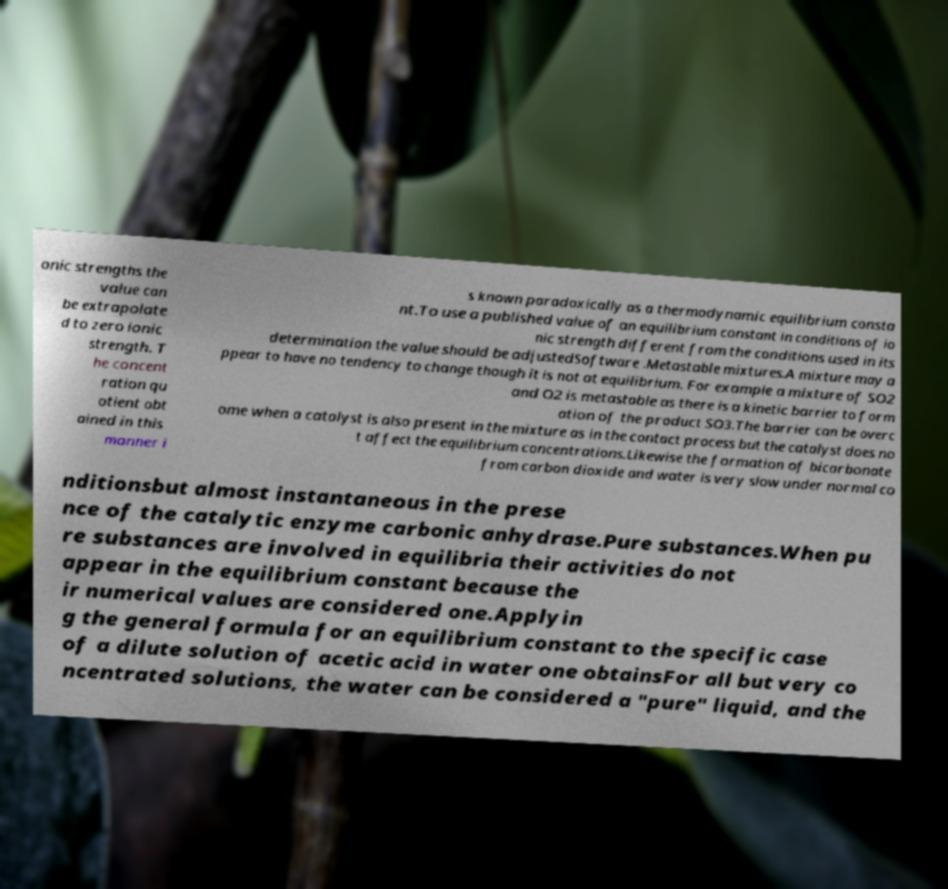Could you extract and type out the text from this image? onic strengths the value can be extrapolate d to zero ionic strength. T he concent ration qu otient obt ained in this manner i s known paradoxically as a thermodynamic equilibrium consta nt.To use a published value of an equilibrium constant in conditions of io nic strength different from the conditions used in its determination the value should be adjustedSoftware .Metastable mixtures.A mixture may a ppear to have no tendency to change though it is not at equilibrium. For example a mixture of SO2 and O2 is metastable as there is a kinetic barrier to form ation of the product SO3.The barrier can be overc ome when a catalyst is also present in the mixture as in the contact process but the catalyst does no t affect the equilibrium concentrations.Likewise the formation of bicarbonate from carbon dioxide and water is very slow under normal co nditionsbut almost instantaneous in the prese nce of the catalytic enzyme carbonic anhydrase.Pure substances.When pu re substances are involved in equilibria their activities do not appear in the equilibrium constant because the ir numerical values are considered one.Applyin g the general formula for an equilibrium constant to the specific case of a dilute solution of acetic acid in water one obtainsFor all but very co ncentrated solutions, the water can be considered a "pure" liquid, and the 